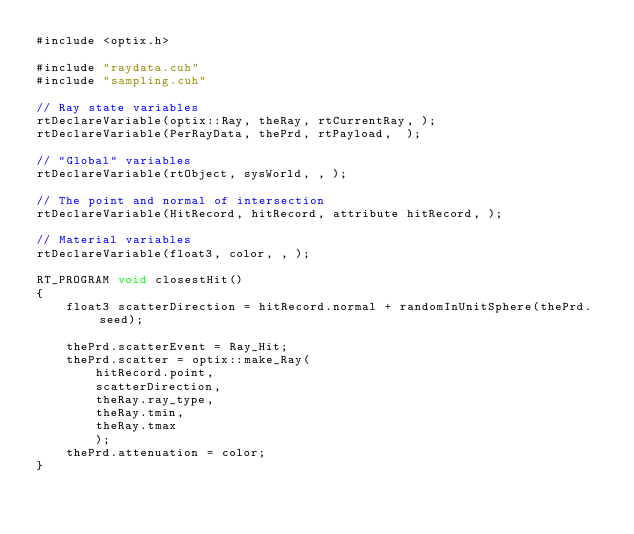Convert code to text. <code><loc_0><loc_0><loc_500><loc_500><_Cuda_>#include <optix.h>

#include "raydata.cuh"
#include "sampling.cuh"

// Ray state variables
rtDeclareVariable(optix::Ray, theRay, rtCurrentRay, );
rtDeclareVariable(PerRayData, thePrd, rtPayload,  );

// "Global" variables
rtDeclareVariable(rtObject, sysWorld, , );

// The point and normal of intersection
rtDeclareVariable(HitRecord, hitRecord, attribute hitRecord, );

// Material variables
rtDeclareVariable(float3, color, , );

RT_PROGRAM void closestHit()
{
    float3 scatterDirection = hitRecord.normal + randomInUnitSphere(thePrd.seed);

    thePrd.scatterEvent = Ray_Hit;
    thePrd.scatter = optix::make_Ray(
        hitRecord.point,
        scatterDirection,
        theRay.ray_type,
        theRay.tmin,
        theRay.tmax
        );
    thePrd.attenuation = color;
}
</code> 